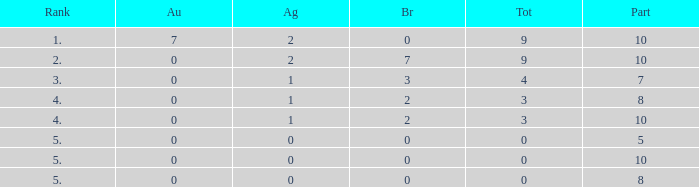What is listed as the highest Participants that also have a Rank of 5, and Silver that's smaller than 0? None. 